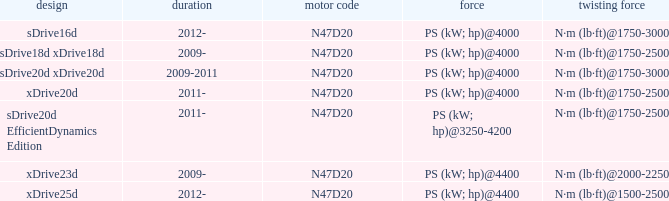What model is the n·m (lb·ft)@1500-2500 torque? Xdrive25d. 